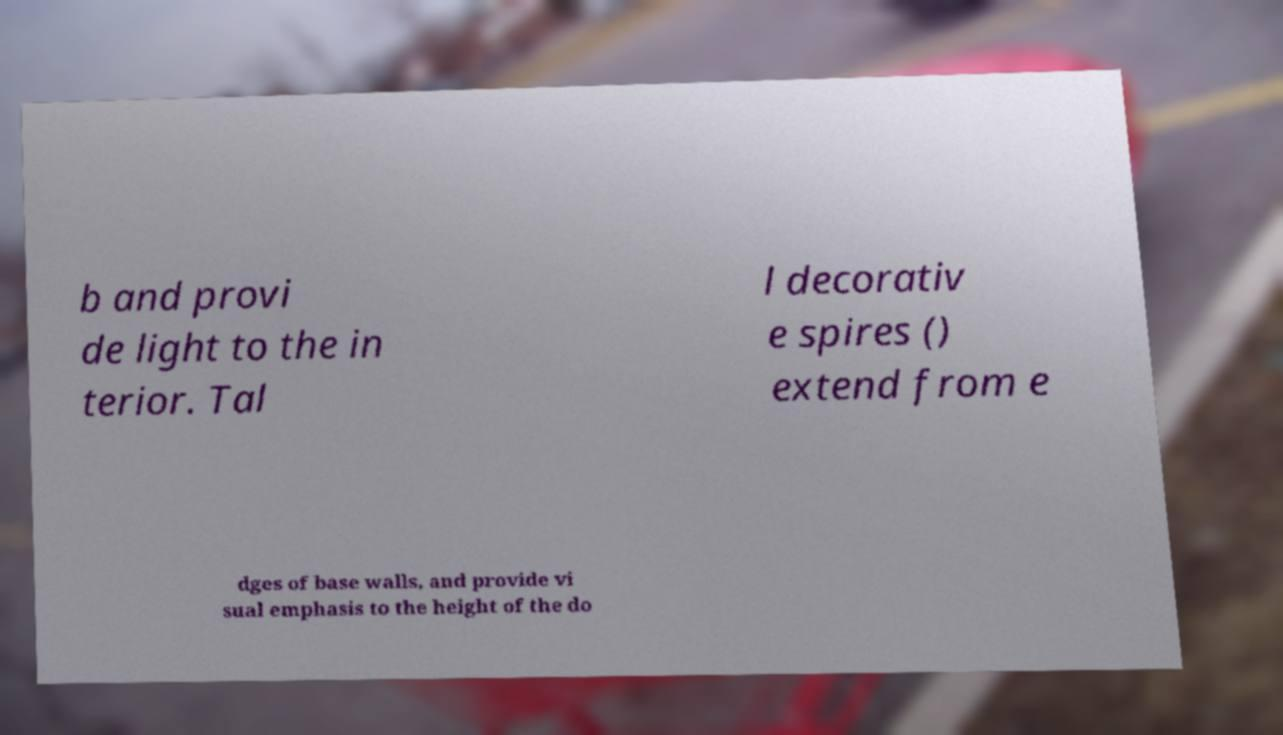Please read and relay the text visible in this image. What does it say? b and provi de light to the in terior. Tal l decorativ e spires () extend from e dges of base walls, and provide vi sual emphasis to the height of the do 